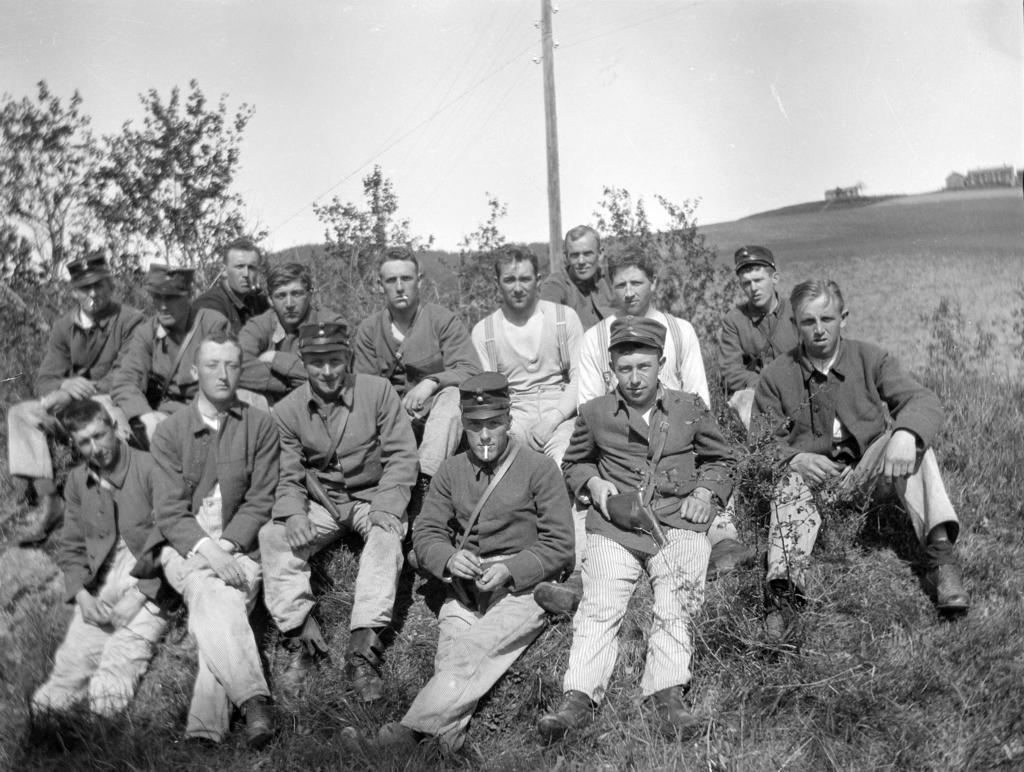In one or two sentences, can you explain what this image depicts? This is a black and white picture. Here we can see people are sitting on the ground. There are plants, grass, pole, and trees. In the background there is sky. 